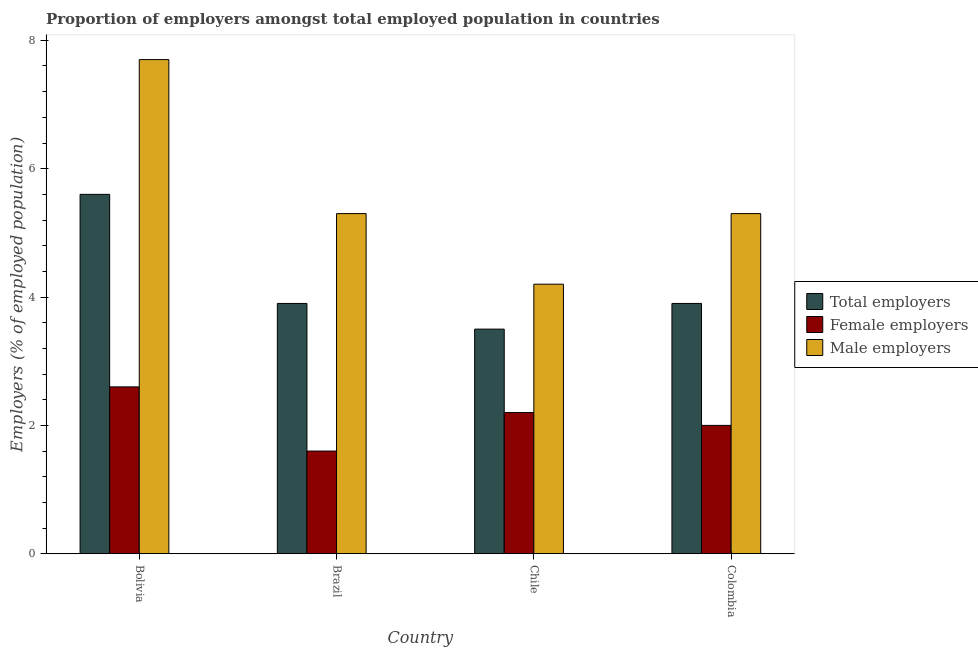How many groups of bars are there?
Give a very brief answer. 4. Are the number of bars on each tick of the X-axis equal?
Offer a very short reply. Yes. How many bars are there on the 3rd tick from the right?
Your answer should be compact. 3. What is the label of the 3rd group of bars from the left?
Ensure brevity in your answer.  Chile. In how many cases, is the number of bars for a given country not equal to the number of legend labels?
Your answer should be very brief. 0. What is the percentage of female employers in Brazil?
Offer a terse response. 1.6. Across all countries, what is the maximum percentage of total employers?
Keep it short and to the point. 5.6. Across all countries, what is the minimum percentage of female employers?
Ensure brevity in your answer.  1.6. In which country was the percentage of male employers maximum?
Ensure brevity in your answer.  Bolivia. What is the total percentage of male employers in the graph?
Keep it short and to the point. 22.5. What is the difference between the percentage of total employers in Bolivia and that in Chile?
Provide a short and direct response. 2.1. What is the difference between the percentage of female employers in Bolivia and the percentage of total employers in Chile?
Ensure brevity in your answer.  -0.9. What is the average percentage of male employers per country?
Your answer should be very brief. 5.63. What is the difference between the percentage of male employers and percentage of female employers in Bolivia?
Make the answer very short. 5.1. In how many countries, is the percentage of total employers greater than 4.8 %?
Your answer should be very brief. 1. What is the ratio of the percentage of total employers in Chile to that in Colombia?
Your response must be concise. 0.9. Is the percentage of male employers in Brazil less than that in Colombia?
Provide a succinct answer. No. What is the difference between the highest and the second highest percentage of female employers?
Make the answer very short. 0.4. What is the difference between the highest and the lowest percentage of female employers?
Offer a very short reply. 1. What does the 3rd bar from the left in Bolivia represents?
Provide a succinct answer. Male employers. What does the 3rd bar from the right in Bolivia represents?
Keep it short and to the point. Total employers. Is it the case that in every country, the sum of the percentage of total employers and percentage of female employers is greater than the percentage of male employers?
Keep it short and to the point. Yes. Are all the bars in the graph horizontal?
Your answer should be compact. No. How many countries are there in the graph?
Keep it short and to the point. 4. Are the values on the major ticks of Y-axis written in scientific E-notation?
Offer a terse response. No. Does the graph contain grids?
Make the answer very short. No. How are the legend labels stacked?
Ensure brevity in your answer.  Vertical. What is the title of the graph?
Make the answer very short. Proportion of employers amongst total employed population in countries. Does "Transport equipments" appear as one of the legend labels in the graph?
Provide a short and direct response. No. What is the label or title of the Y-axis?
Ensure brevity in your answer.  Employers (% of employed population). What is the Employers (% of employed population) of Total employers in Bolivia?
Your answer should be very brief. 5.6. What is the Employers (% of employed population) of Female employers in Bolivia?
Keep it short and to the point. 2.6. What is the Employers (% of employed population) in Male employers in Bolivia?
Give a very brief answer. 7.7. What is the Employers (% of employed population) of Total employers in Brazil?
Your answer should be compact. 3.9. What is the Employers (% of employed population) of Female employers in Brazil?
Your answer should be compact. 1.6. What is the Employers (% of employed population) in Male employers in Brazil?
Provide a short and direct response. 5.3. What is the Employers (% of employed population) in Total employers in Chile?
Give a very brief answer. 3.5. What is the Employers (% of employed population) in Female employers in Chile?
Give a very brief answer. 2.2. What is the Employers (% of employed population) of Male employers in Chile?
Provide a short and direct response. 4.2. What is the Employers (% of employed population) of Total employers in Colombia?
Your response must be concise. 3.9. What is the Employers (% of employed population) of Female employers in Colombia?
Give a very brief answer. 2. What is the Employers (% of employed population) of Male employers in Colombia?
Offer a very short reply. 5.3. Across all countries, what is the maximum Employers (% of employed population) of Total employers?
Your answer should be compact. 5.6. Across all countries, what is the maximum Employers (% of employed population) in Female employers?
Provide a short and direct response. 2.6. Across all countries, what is the maximum Employers (% of employed population) in Male employers?
Provide a succinct answer. 7.7. Across all countries, what is the minimum Employers (% of employed population) in Total employers?
Your response must be concise. 3.5. Across all countries, what is the minimum Employers (% of employed population) of Female employers?
Keep it short and to the point. 1.6. Across all countries, what is the minimum Employers (% of employed population) of Male employers?
Offer a very short reply. 4.2. What is the total Employers (% of employed population) of Total employers in the graph?
Provide a succinct answer. 16.9. What is the difference between the Employers (% of employed population) in Total employers in Bolivia and that in Brazil?
Make the answer very short. 1.7. What is the difference between the Employers (% of employed population) in Total employers in Bolivia and that in Chile?
Provide a succinct answer. 2.1. What is the difference between the Employers (% of employed population) of Female employers in Bolivia and that in Chile?
Offer a very short reply. 0.4. What is the difference between the Employers (% of employed population) in Total employers in Bolivia and that in Colombia?
Provide a short and direct response. 1.7. What is the difference between the Employers (% of employed population) of Male employers in Bolivia and that in Colombia?
Make the answer very short. 2.4. What is the difference between the Employers (% of employed population) of Total employers in Brazil and that in Colombia?
Offer a terse response. 0. What is the difference between the Employers (% of employed population) in Female employers in Brazil and that in Colombia?
Ensure brevity in your answer.  -0.4. What is the difference between the Employers (% of employed population) in Female employers in Chile and that in Colombia?
Provide a short and direct response. 0.2. What is the difference between the Employers (% of employed population) in Male employers in Chile and that in Colombia?
Keep it short and to the point. -1.1. What is the difference between the Employers (% of employed population) of Total employers in Bolivia and the Employers (% of employed population) of Female employers in Brazil?
Provide a short and direct response. 4. What is the difference between the Employers (% of employed population) of Total employers in Bolivia and the Employers (% of employed population) of Male employers in Brazil?
Your answer should be compact. 0.3. What is the difference between the Employers (% of employed population) in Female employers in Bolivia and the Employers (% of employed population) in Male employers in Brazil?
Provide a succinct answer. -2.7. What is the difference between the Employers (% of employed population) of Total employers in Bolivia and the Employers (% of employed population) of Female employers in Colombia?
Give a very brief answer. 3.6. What is the difference between the Employers (% of employed population) in Total employers in Brazil and the Employers (% of employed population) in Male employers in Chile?
Keep it short and to the point. -0.3. What is the difference between the Employers (% of employed population) of Female employers in Brazil and the Employers (% of employed population) of Male employers in Chile?
Your response must be concise. -2.6. What is the difference between the Employers (% of employed population) in Total employers in Brazil and the Employers (% of employed population) in Male employers in Colombia?
Make the answer very short. -1.4. What is the difference between the Employers (% of employed population) in Total employers in Chile and the Employers (% of employed population) in Female employers in Colombia?
Keep it short and to the point. 1.5. What is the difference between the Employers (% of employed population) in Total employers in Chile and the Employers (% of employed population) in Male employers in Colombia?
Offer a very short reply. -1.8. What is the difference between the Employers (% of employed population) in Female employers in Chile and the Employers (% of employed population) in Male employers in Colombia?
Provide a succinct answer. -3.1. What is the average Employers (% of employed population) of Total employers per country?
Make the answer very short. 4.22. What is the average Employers (% of employed population) of Female employers per country?
Ensure brevity in your answer.  2.1. What is the average Employers (% of employed population) in Male employers per country?
Ensure brevity in your answer.  5.62. What is the difference between the Employers (% of employed population) of Female employers and Employers (% of employed population) of Male employers in Bolivia?
Your response must be concise. -5.1. What is the difference between the Employers (% of employed population) of Total employers and Employers (% of employed population) of Female employers in Brazil?
Offer a very short reply. 2.3. What is the difference between the Employers (% of employed population) of Total employers and Employers (% of employed population) of Female employers in Chile?
Provide a short and direct response. 1.3. What is the difference between the Employers (% of employed population) of Female employers and Employers (% of employed population) of Male employers in Chile?
Offer a very short reply. -2. What is the difference between the Employers (% of employed population) of Total employers and Employers (% of employed population) of Female employers in Colombia?
Make the answer very short. 1.9. What is the difference between the Employers (% of employed population) of Female employers and Employers (% of employed population) of Male employers in Colombia?
Provide a succinct answer. -3.3. What is the ratio of the Employers (% of employed population) in Total employers in Bolivia to that in Brazil?
Your response must be concise. 1.44. What is the ratio of the Employers (% of employed population) in Female employers in Bolivia to that in Brazil?
Provide a succinct answer. 1.62. What is the ratio of the Employers (% of employed population) in Male employers in Bolivia to that in Brazil?
Give a very brief answer. 1.45. What is the ratio of the Employers (% of employed population) in Total employers in Bolivia to that in Chile?
Keep it short and to the point. 1.6. What is the ratio of the Employers (% of employed population) in Female employers in Bolivia to that in Chile?
Ensure brevity in your answer.  1.18. What is the ratio of the Employers (% of employed population) of Male employers in Bolivia to that in Chile?
Offer a terse response. 1.83. What is the ratio of the Employers (% of employed population) in Total employers in Bolivia to that in Colombia?
Keep it short and to the point. 1.44. What is the ratio of the Employers (% of employed population) of Female employers in Bolivia to that in Colombia?
Your answer should be very brief. 1.3. What is the ratio of the Employers (% of employed population) of Male employers in Bolivia to that in Colombia?
Give a very brief answer. 1.45. What is the ratio of the Employers (% of employed population) of Total employers in Brazil to that in Chile?
Give a very brief answer. 1.11. What is the ratio of the Employers (% of employed population) in Female employers in Brazil to that in Chile?
Ensure brevity in your answer.  0.73. What is the ratio of the Employers (% of employed population) in Male employers in Brazil to that in Chile?
Your answer should be very brief. 1.26. What is the ratio of the Employers (% of employed population) in Total employers in Brazil to that in Colombia?
Provide a succinct answer. 1. What is the ratio of the Employers (% of employed population) in Male employers in Brazil to that in Colombia?
Keep it short and to the point. 1. What is the ratio of the Employers (% of employed population) in Total employers in Chile to that in Colombia?
Provide a succinct answer. 0.9. What is the ratio of the Employers (% of employed population) of Male employers in Chile to that in Colombia?
Keep it short and to the point. 0.79. What is the difference between the highest and the second highest Employers (% of employed population) of Male employers?
Give a very brief answer. 2.4. What is the difference between the highest and the lowest Employers (% of employed population) in Total employers?
Give a very brief answer. 2.1. What is the difference between the highest and the lowest Employers (% of employed population) of Male employers?
Offer a terse response. 3.5. 